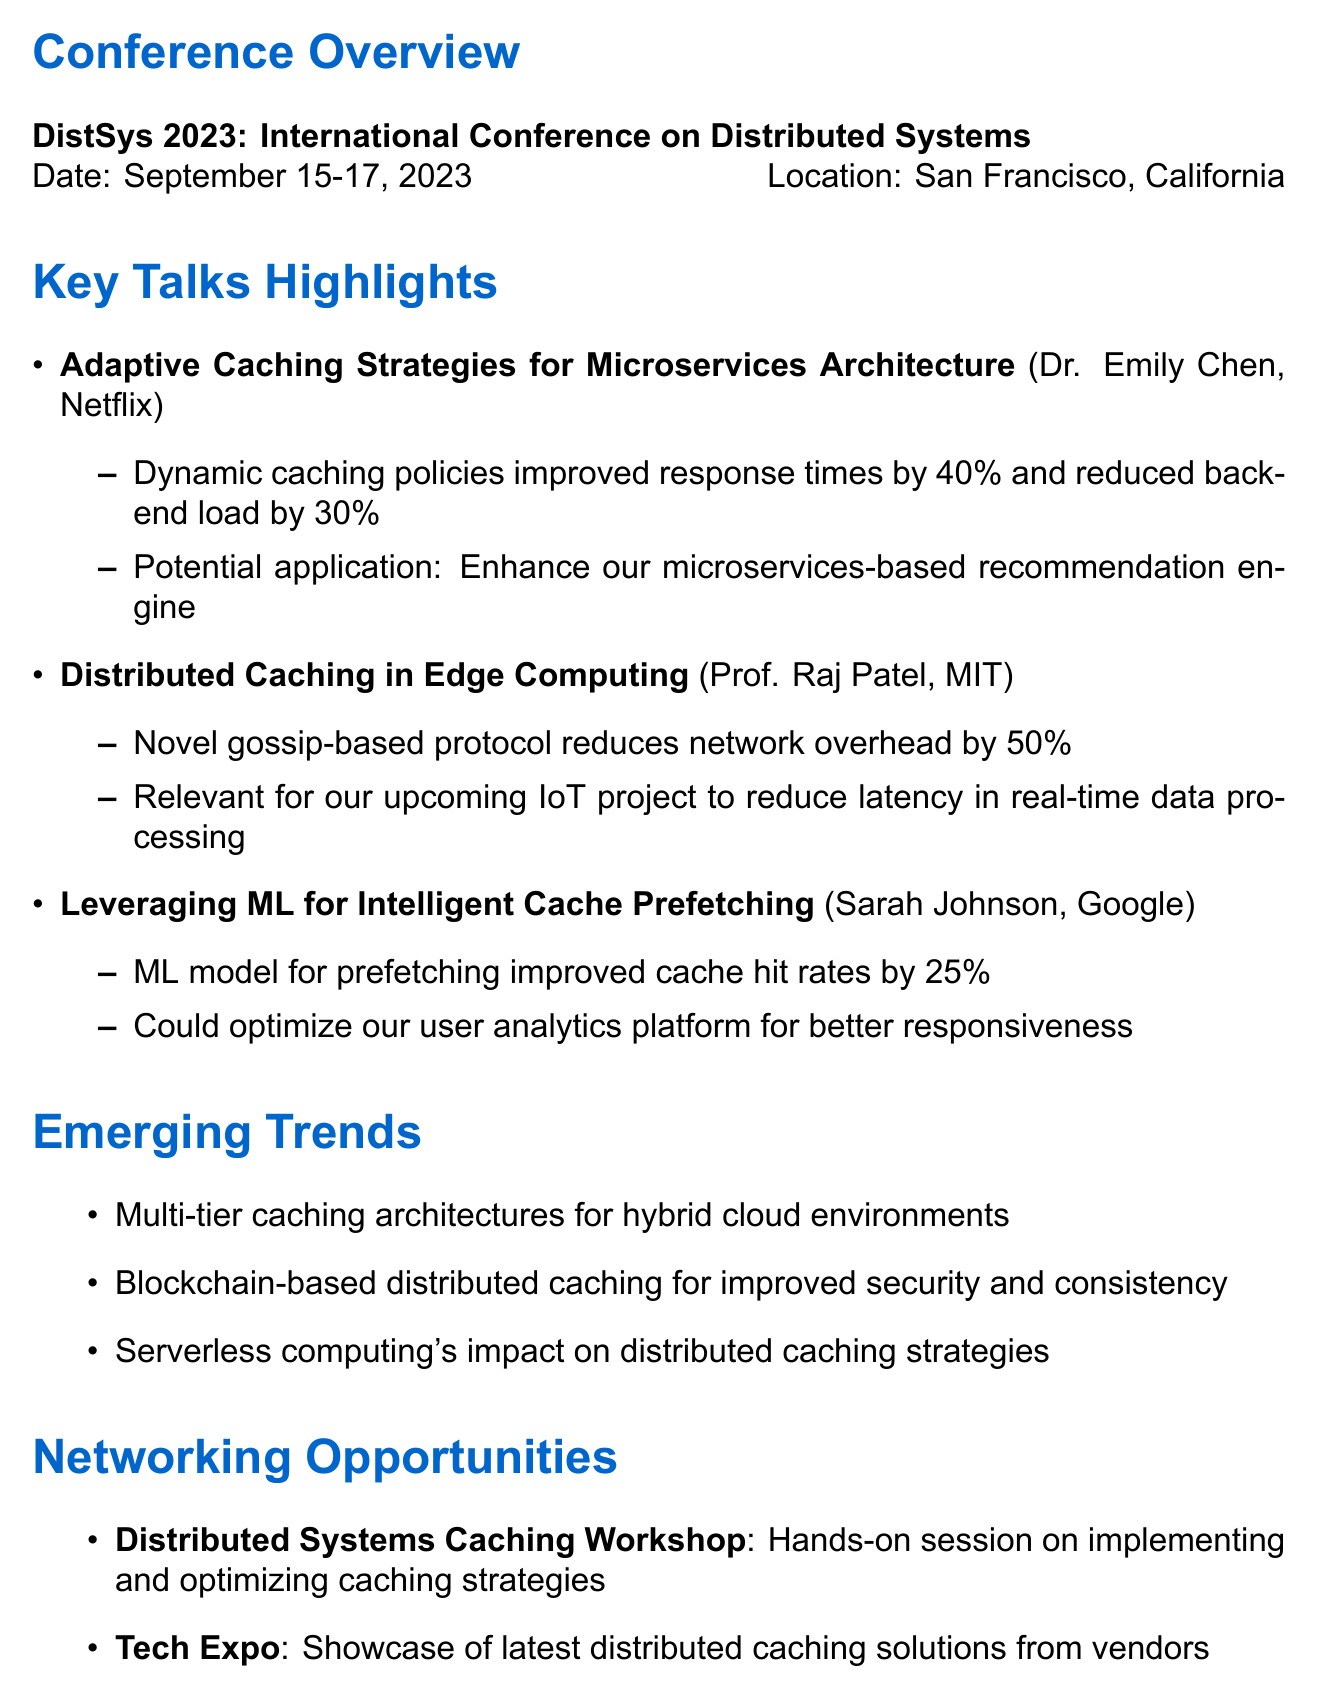What is the name of the conference? The name of the conference is stated in the document and is "DistSys 2023: International Conference on Distributed Systems."
Answer: DistSys 2023: International Conference on Distributed Systems Who is the speaker for the session on Adaptive Caching Strategies? The speaker's name for this session is provided in the document under the key talks section.
Answer: Dr. Emily Chen What was the improvement in response times mentioned by Dr. Emily Chen? The document specifies that adaptive caching improved response times by 40%.
Answer: 40% Which technique was proposed by Prof. Raj Patel to address cache coherence? The document mentions a "novel gossip-based protocol" proposed by Prof. Raj Patel.
Answer: novel gossip-based protocol What percentage improvement in cache hit rates was presented by Sarah Johnson? The document indicates that Sarah Johnson's model resulted in a 25% improvement in cache hit rates.
Answer: 25% What is one of the emerging trends mentioned in the memo? The memo lists several trends, one of which is "Multi-tier caching architectures for hybrid cloud environments."
Answer: Multi-tier caching architectures for hybrid cloud environments What type of session is the Distributed Systems Caching Workshop? The document characterizes this session as a "hands-on session."
Answer: hands-on session How many key takeaways are listed in the document? The memo enumerates a specific number of key takeaways in a bulleted list.
Answer: Four 